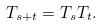<formula> <loc_0><loc_0><loc_500><loc_500>T _ { s + t } = T _ { s } T _ { t } .</formula> 